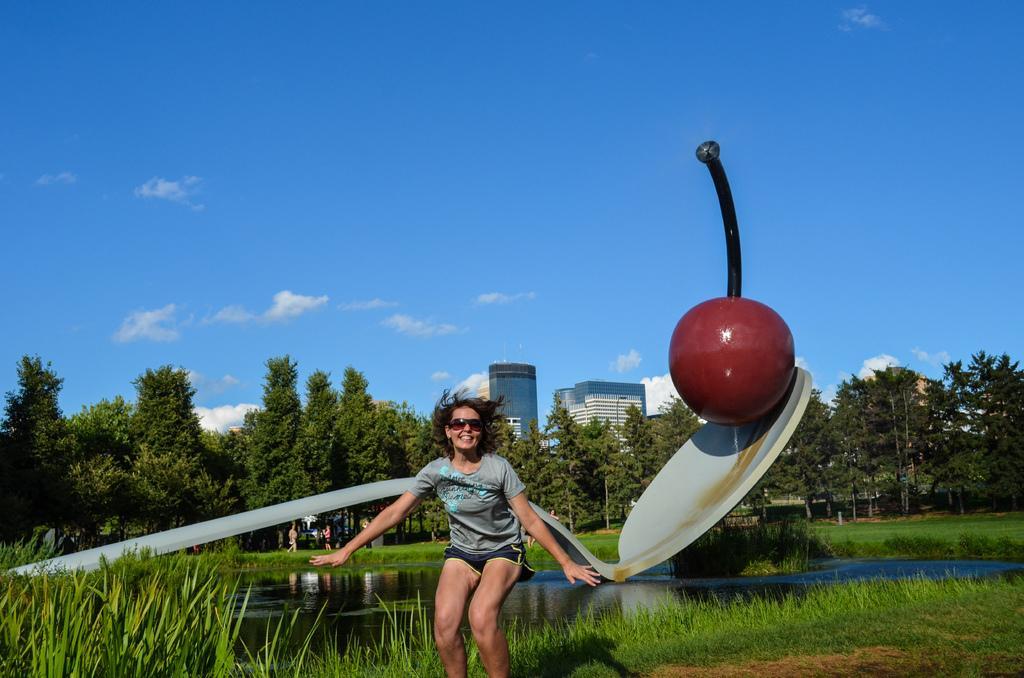Describe this image in one or two sentences. In this image there is a person standing and smiling, and there is grass, water, statue of a cherry on the spoon, trees, buildings, and in the background there is sky. 